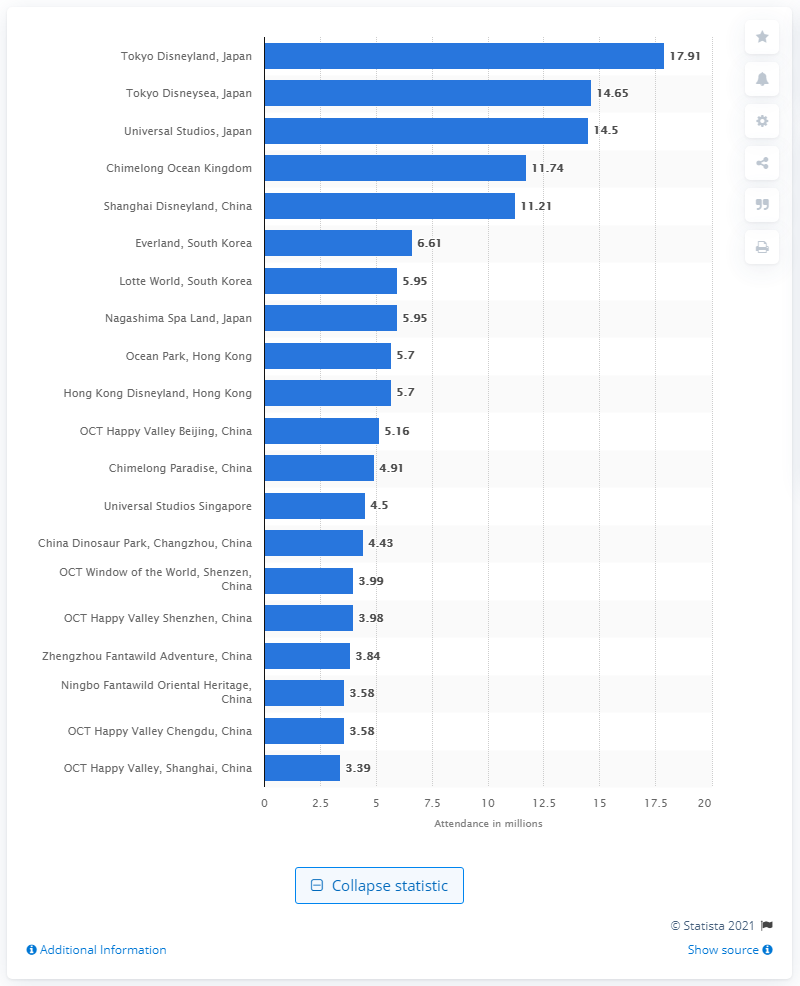Point out several critical features in this image. In 2019, 17,910 visitors visited Tokyo Disneyland. The number of visitors to Happy Valley in 2019 was 3,390. 